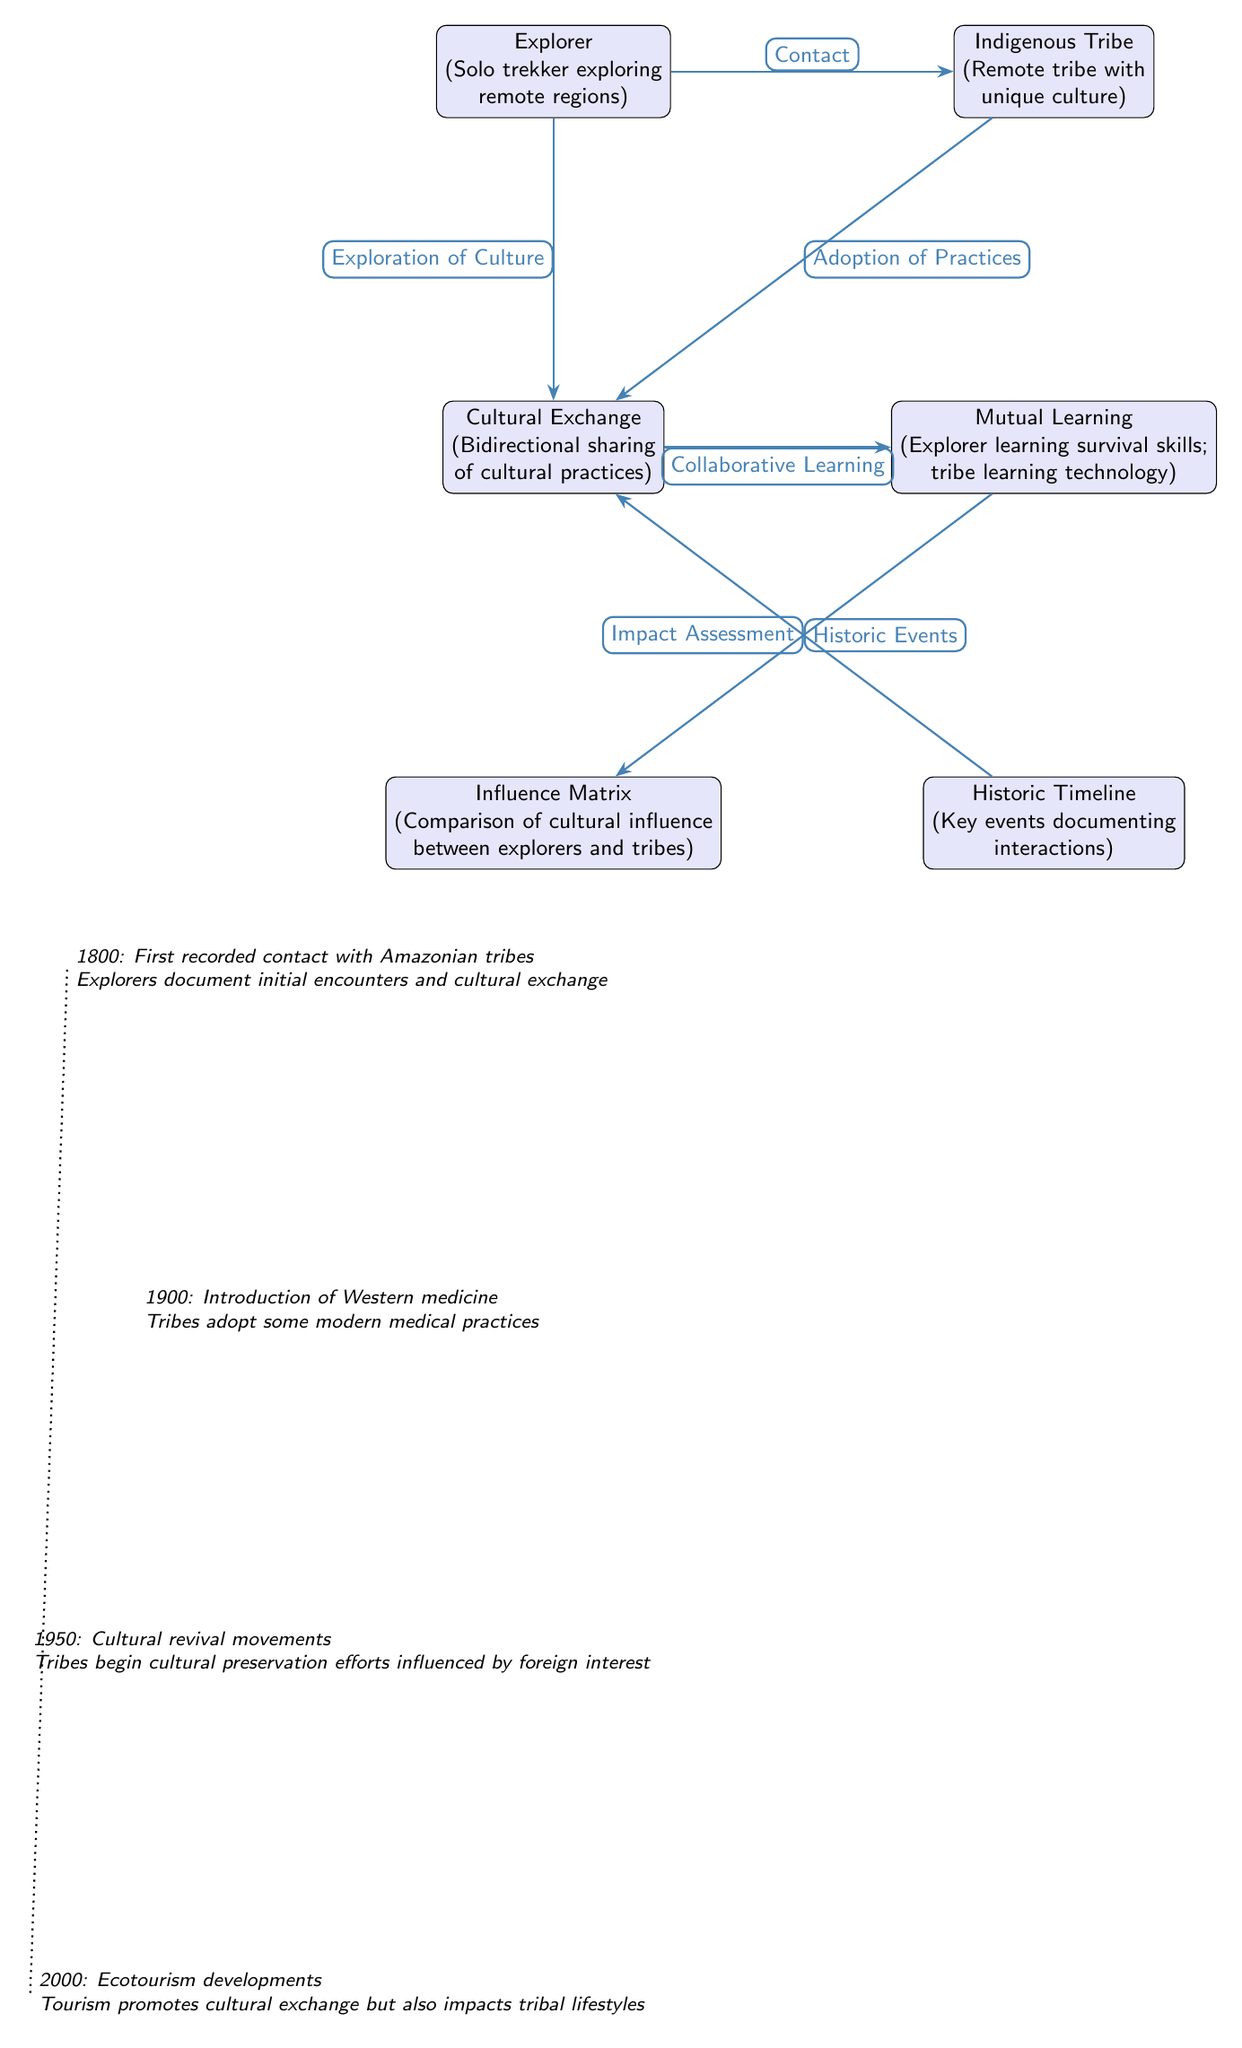What type of cultural interaction is depicted between the explorer and the indigenous tribe? The diagram highlights "Cultural Exchange" as the type of interaction between the explorer and the tribe, indicating mutual sharing of cultural practices.
Answer: Cultural Exchange How many nodes are present in the diagram? Counting all the distinct labeled entities in the diagram, there are six nodes: Explorer, Indigenous Tribe, Cultural Exchange, Mutual Learning, Influence Matrix, and Historic Timeline.
Answer: Six What impact is noted from the collaboration between the explorer and the indigenous tribe? The relationship indicates "Collaborative Learning," where both parties benefit from each other's knowledge and practices, such as survival skills and technology.
Answer: Collaborative Learning What year marks the first recorded contact with Amazonian tribes? The timeline indicates 1800 as the year of the first recorded contact with Amazonian tribes, which is documented in the historic events section.
Answer: 1800 Which event in the timeline relates to the tribes adopting modern medical practices? The year 1900 is specified in the timeline, indicating the introduction of Western medicine, leading to tribes adopting some modern medical practices.
Answer: 1900 What connects the "Historic Events" node to the "Cultural Exchange" node? The connection is described as "Historic Events," which emphasizes the significant interactions and exchanges that took place chronologically in the timeline presented.
Answer: Historic Events What process is described in the Influence Matrix node? The Influence Matrix describes the "Comparison of cultural influence between explorers and tribes," indicating a measure of the impact each had on the other.
Answer: Comparison of cultural influence Which influence did the cultural revival movements have on the tribes, as reflected in the timeline? The timeline mentions that in 1950, tribal cultural preservation efforts were influenced by foreign interest, indicating a revival of their traditions.
Answer: Cultural preservation efforts What technology-related aspect did the explorations lead to for the indigenous tribe? The Mutual Learning node indicates that the tribe learned technology from the explorer, highlighting a transfer of knowledge resulting from their interaction.
Answer: Technology 